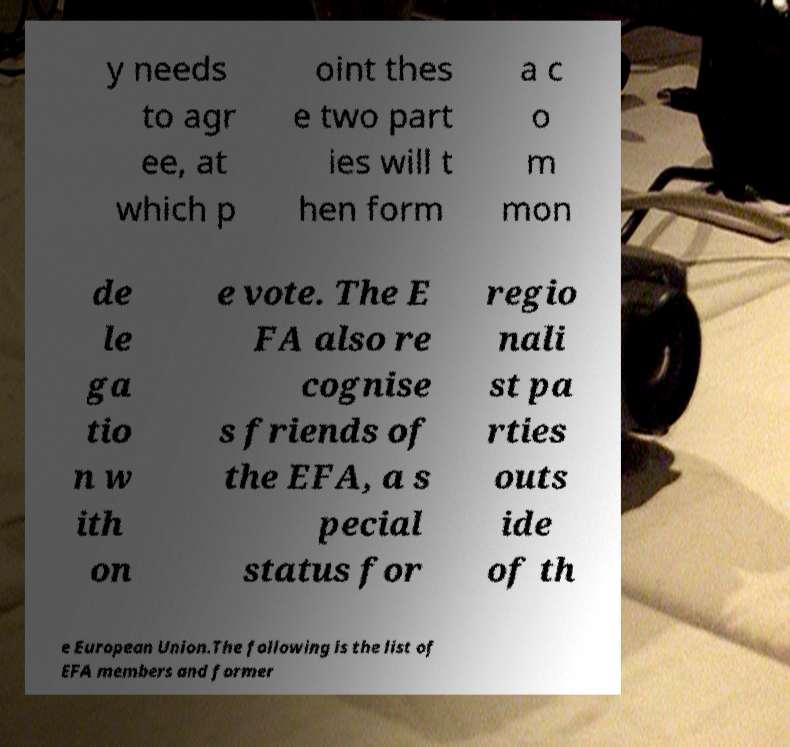For documentation purposes, I need the text within this image transcribed. Could you provide that? y needs to agr ee, at which p oint thes e two part ies will t hen form a c o m mon de le ga tio n w ith on e vote. The E FA also re cognise s friends of the EFA, a s pecial status for regio nali st pa rties outs ide of th e European Union.The following is the list of EFA members and former 